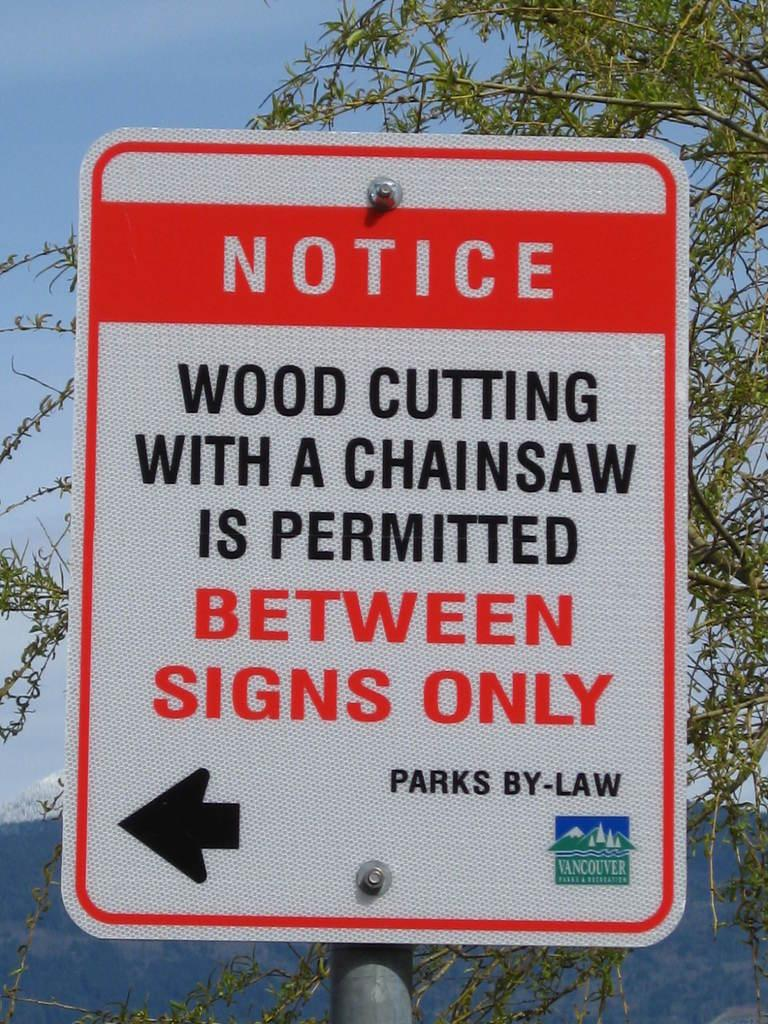<image>
Relay a brief, clear account of the picture shown. a sign that has the word notice at the top 